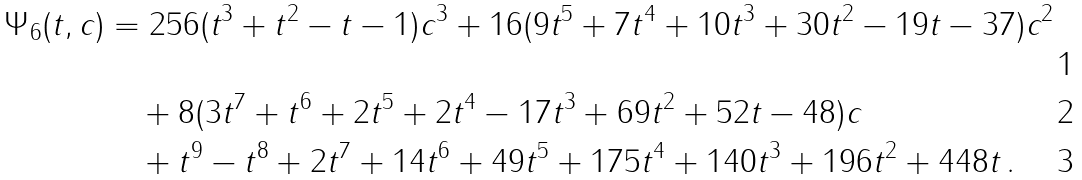<formula> <loc_0><loc_0><loc_500><loc_500>\Psi _ { 6 } ( t , c ) & = 2 5 6 ( t ^ { 3 } + t ^ { 2 } - t - 1 ) c ^ { 3 } + 1 6 ( 9 t ^ { 5 } + 7 t ^ { 4 } + 1 0 t ^ { 3 } + 3 0 t ^ { 2 } - 1 9 t - 3 7 ) c ^ { 2 } \\ & \quad + 8 ( 3 t ^ { 7 } + t ^ { 6 } + 2 t ^ { 5 } + 2 t ^ { 4 } - 1 7 t ^ { 3 } + 6 9 t ^ { 2 } + 5 2 t - 4 8 ) c \\ & \quad + t ^ { 9 } - t ^ { 8 } + 2 t ^ { 7 } + 1 4 t ^ { 6 } + 4 9 t ^ { 5 } + 1 7 5 t ^ { 4 } + 1 4 0 t ^ { 3 } + 1 9 6 t ^ { 2 } + 4 4 8 t \, .</formula> 